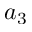Convert formula to latex. <formula><loc_0><loc_0><loc_500><loc_500>a _ { 3 }</formula> 